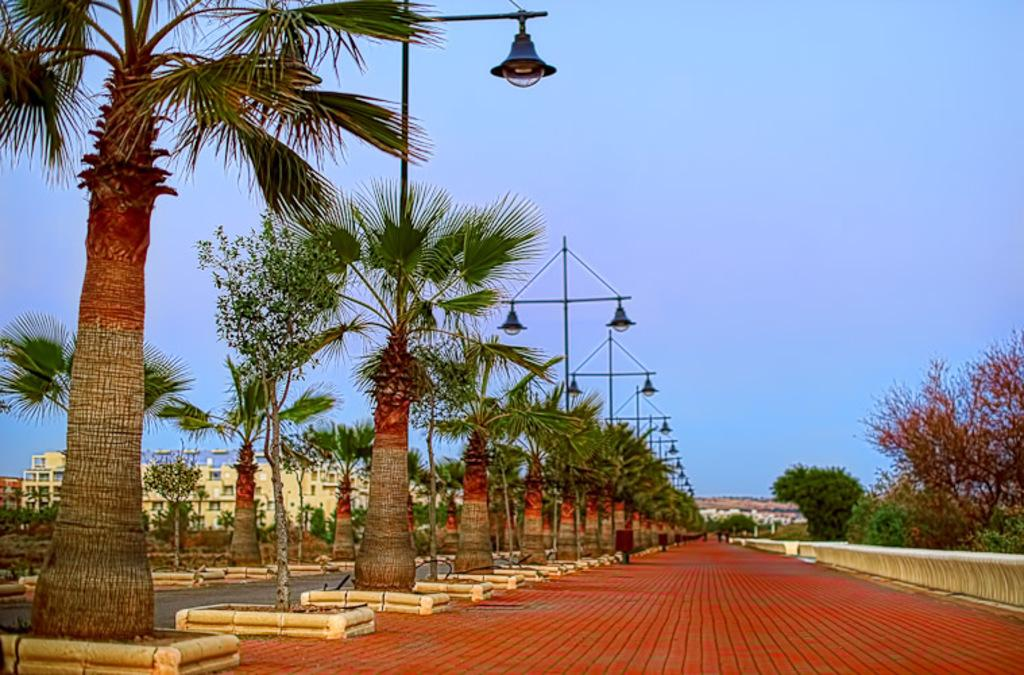What type of vegetation can be seen in the image? There are trees in the image. What color are the trees? The trees are green. What else can be seen in the image besides the trees? There are light poles in the image. What is visible in the background of the image? There is a building in the background of the image. What color is the building? The building is cream-colored. What is the color of the sky in the image? The sky is blue. How much waste is being disposed of in the image? There is no indication of waste disposal in the image. What type of van can be seen parked near the trees? There is no van present in the image. 